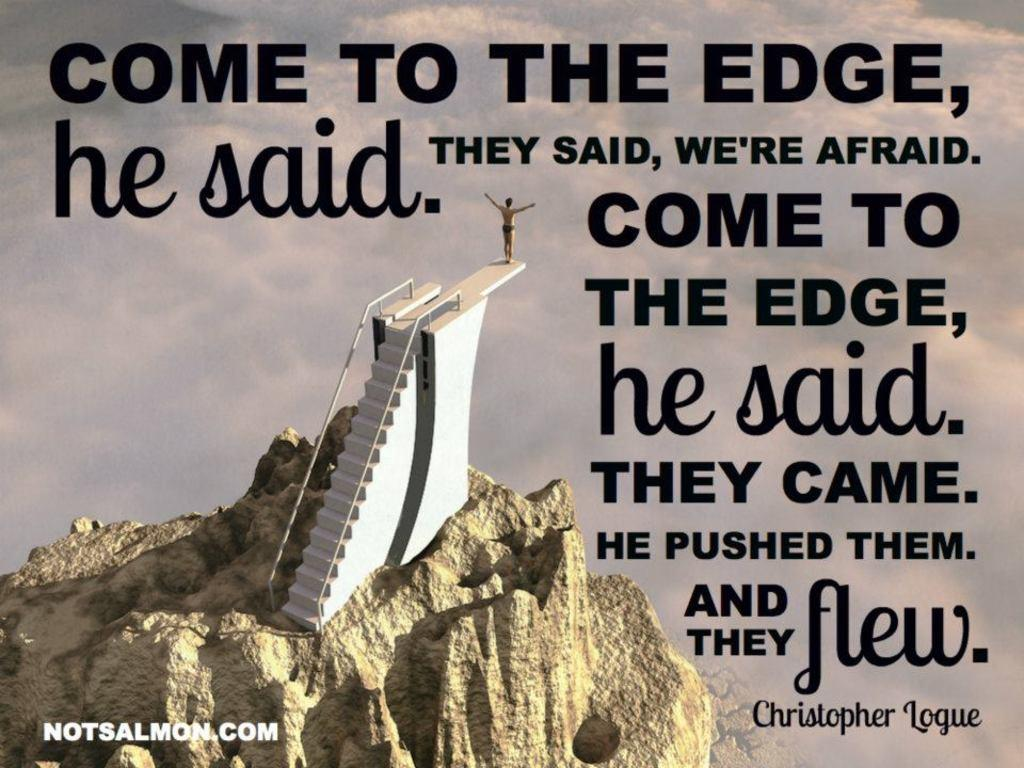Provide a one-sentence caption for the provided image. A quote by Christopher Logue on an image of a man on a diving board at the top of a mountain. 